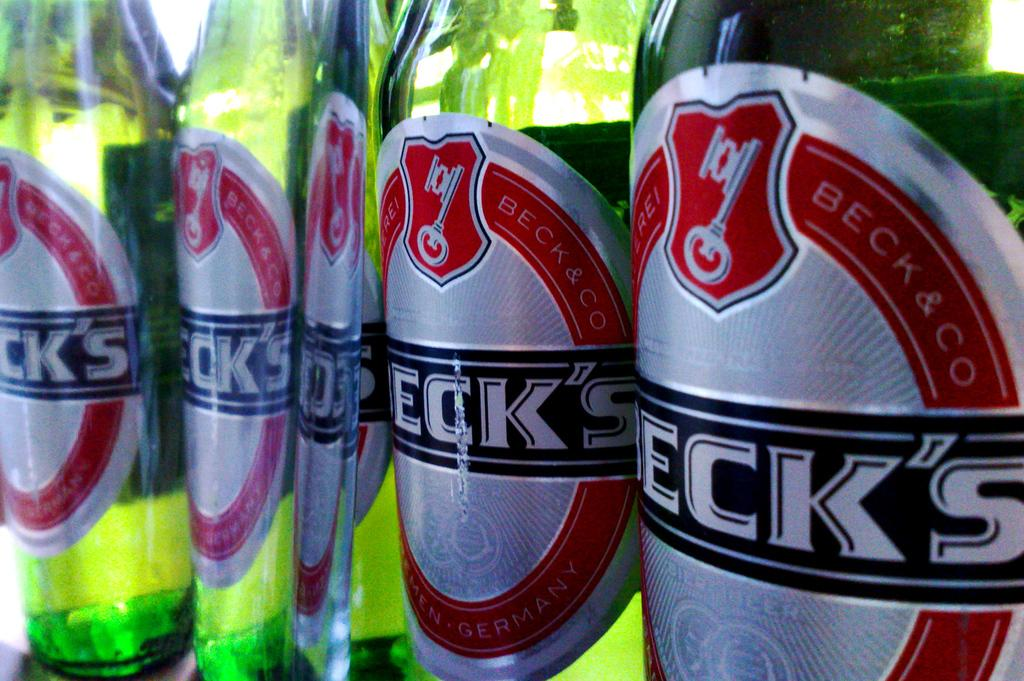<image>
Render a clear and concise summary of the photo. Bottles of beck's beer are all stood next to each other. 